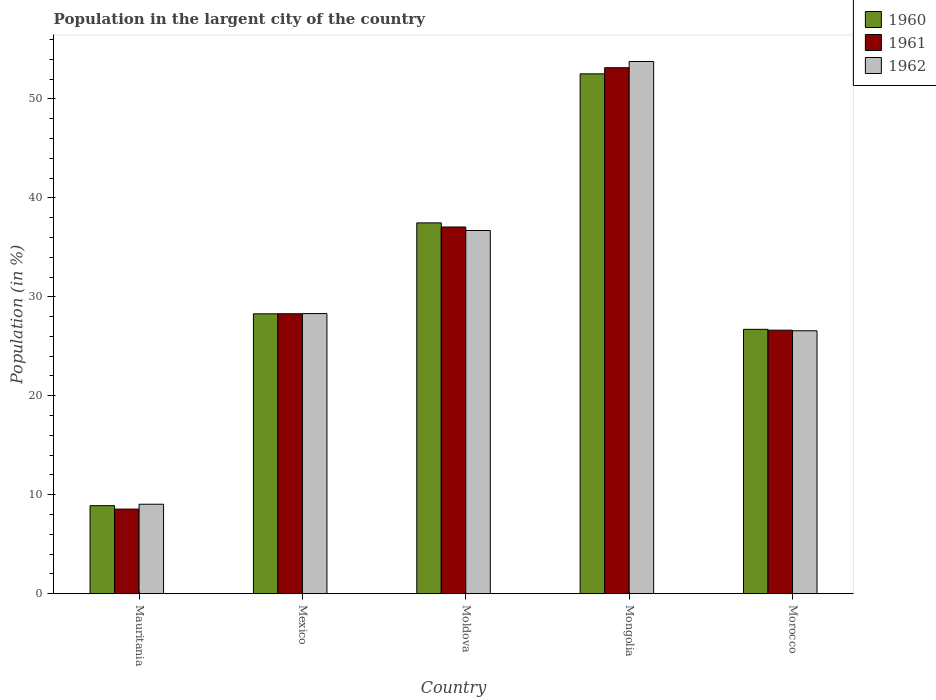How many different coloured bars are there?
Keep it short and to the point. 3. Are the number of bars per tick equal to the number of legend labels?
Offer a very short reply. Yes. How many bars are there on the 5th tick from the left?
Make the answer very short. 3. How many bars are there on the 4th tick from the right?
Keep it short and to the point. 3. What is the label of the 3rd group of bars from the left?
Make the answer very short. Moldova. In how many cases, is the number of bars for a given country not equal to the number of legend labels?
Offer a very short reply. 0. What is the percentage of population in the largent city in 1962 in Moldova?
Provide a succinct answer. 36.7. Across all countries, what is the maximum percentage of population in the largent city in 1962?
Your response must be concise. 53.77. Across all countries, what is the minimum percentage of population in the largent city in 1960?
Keep it short and to the point. 8.9. In which country was the percentage of population in the largent city in 1961 maximum?
Your answer should be compact. Mongolia. In which country was the percentage of population in the largent city in 1962 minimum?
Ensure brevity in your answer.  Mauritania. What is the total percentage of population in the largent city in 1961 in the graph?
Provide a short and direct response. 153.66. What is the difference between the percentage of population in the largent city in 1960 in Moldova and that in Morocco?
Your answer should be compact. 10.76. What is the difference between the percentage of population in the largent city in 1961 in Moldova and the percentage of population in the largent city in 1960 in Mauritania?
Provide a succinct answer. 28.15. What is the average percentage of population in the largent city in 1960 per country?
Provide a short and direct response. 30.78. What is the difference between the percentage of population in the largent city of/in 1961 and percentage of population in the largent city of/in 1960 in Mauritania?
Offer a terse response. -0.35. What is the ratio of the percentage of population in the largent city in 1960 in Moldova to that in Morocco?
Ensure brevity in your answer.  1.4. What is the difference between the highest and the second highest percentage of population in the largent city in 1962?
Your answer should be compact. -8.39. What is the difference between the highest and the lowest percentage of population in the largent city in 1962?
Ensure brevity in your answer.  44.73. In how many countries, is the percentage of population in the largent city in 1961 greater than the average percentage of population in the largent city in 1961 taken over all countries?
Offer a very short reply. 2. Is the sum of the percentage of population in the largent city in 1960 in Mongolia and Morocco greater than the maximum percentage of population in the largent city in 1961 across all countries?
Ensure brevity in your answer.  Yes. What does the 1st bar from the right in Mongolia represents?
Offer a very short reply. 1962. How many bars are there?
Your response must be concise. 15. What is the difference between two consecutive major ticks on the Y-axis?
Ensure brevity in your answer.  10. Does the graph contain any zero values?
Offer a very short reply. No. How many legend labels are there?
Offer a terse response. 3. How are the legend labels stacked?
Offer a very short reply. Vertical. What is the title of the graph?
Ensure brevity in your answer.  Population in the largent city of the country. What is the Population (in %) in 1960 in Mauritania?
Your answer should be very brief. 8.9. What is the Population (in %) in 1961 in Mauritania?
Make the answer very short. 8.55. What is the Population (in %) of 1962 in Mauritania?
Your answer should be compact. 9.04. What is the Population (in %) of 1960 in Mexico?
Your answer should be compact. 28.28. What is the Population (in %) in 1961 in Mexico?
Your answer should be very brief. 28.29. What is the Population (in %) in 1962 in Mexico?
Give a very brief answer. 28.31. What is the Population (in %) of 1960 in Moldova?
Your response must be concise. 37.47. What is the Population (in %) of 1961 in Moldova?
Your answer should be compact. 37.05. What is the Population (in %) in 1962 in Moldova?
Provide a succinct answer. 36.7. What is the Population (in %) in 1960 in Mongolia?
Provide a succinct answer. 52.52. What is the Population (in %) of 1961 in Mongolia?
Your response must be concise. 53.14. What is the Population (in %) in 1962 in Mongolia?
Your response must be concise. 53.77. What is the Population (in %) in 1960 in Morocco?
Keep it short and to the point. 26.71. What is the Population (in %) in 1961 in Morocco?
Make the answer very short. 26.63. What is the Population (in %) of 1962 in Morocco?
Offer a terse response. 26.57. Across all countries, what is the maximum Population (in %) in 1960?
Your answer should be compact. 52.52. Across all countries, what is the maximum Population (in %) in 1961?
Provide a short and direct response. 53.14. Across all countries, what is the maximum Population (in %) of 1962?
Provide a short and direct response. 53.77. Across all countries, what is the minimum Population (in %) of 1960?
Give a very brief answer. 8.9. Across all countries, what is the minimum Population (in %) in 1961?
Keep it short and to the point. 8.55. Across all countries, what is the minimum Population (in %) of 1962?
Offer a terse response. 9.04. What is the total Population (in %) in 1960 in the graph?
Provide a short and direct response. 153.88. What is the total Population (in %) of 1961 in the graph?
Offer a very short reply. 153.66. What is the total Population (in %) in 1962 in the graph?
Your answer should be very brief. 154.39. What is the difference between the Population (in %) in 1960 in Mauritania and that in Mexico?
Your answer should be very brief. -19.38. What is the difference between the Population (in %) in 1961 in Mauritania and that in Mexico?
Offer a very short reply. -19.73. What is the difference between the Population (in %) of 1962 in Mauritania and that in Mexico?
Offer a very short reply. -19.26. What is the difference between the Population (in %) of 1960 in Mauritania and that in Moldova?
Provide a succinct answer. -28.57. What is the difference between the Population (in %) in 1961 in Mauritania and that in Moldova?
Your answer should be compact. -28.5. What is the difference between the Population (in %) in 1962 in Mauritania and that in Moldova?
Your answer should be compact. -27.66. What is the difference between the Population (in %) of 1960 in Mauritania and that in Mongolia?
Your answer should be compact. -43.62. What is the difference between the Population (in %) of 1961 in Mauritania and that in Mongolia?
Your response must be concise. -44.59. What is the difference between the Population (in %) of 1962 in Mauritania and that in Mongolia?
Offer a terse response. -44.73. What is the difference between the Population (in %) of 1960 in Mauritania and that in Morocco?
Ensure brevity in your answer.  -17.81. What is the difference between the Population (in %) in 1961 in Mauritania and that in Morocco?
Make the answer very short. -18.08. What is the difference between the Population (in %) of 1962 in Mauritania and that in Morocco?
Offer a terse response. -17.53. What is the difference between the Population (in %) of 1960 in Mexico and that in Moldova?
Your answer should be very brief. -9.19. What is the difference between the Population (in %) in 1961 in Mexico and that in Moldova?
Make the answer very short. -8.76. What is the difference between the Population (in %) of 1962 in Mexico and that in Moldova?
Your response must be concise. -8.39. What is the difference between the Population (in %) in 1960 in Mexico and that in Mongolia?
Provide a succinct answer. -24.24. What is the difference between the Population (in %) in 1961 in Mexico and that in Mongolia?
Your response must be concise. -24.86. What is the difference between the Population (in %) of 1962 in Mexico and that in Mongolia?
Provide a succinct answer. -25.47. What is the difference between the Population (in %) of 1960 in Mexico and that in Morocco?
Ensure brevity in your answer.  1.57. What is the difference between the Population (in %) of 1961 in Mexico and that in Morocco?
Provide a short and direct response. 1.66. What is the difference between the Population (in %) of 1962 in Mexico and that in Morocco?
Give a very brief answer. 1.74. What is the difference between the Population (in %) of 1960 in Moldova and that in Mongolia?
Offer a very short reply. -15.05. What is the difference between the Population (in %) of 1961 in Moldova and that in Mongolia?
Provide a short and direct response. -16.09. What is the difference between the Population (in %) of 1962 in Moldova and that in Mongolia?
Offer a very short reply. -17.08. What is the difference between the Population (in %) in 1960 in Moldova and that in Morocco?
Offer a very short reply. 10.76. What is the difference between the Population (in %) of 1961 in Moldova and that in Morocco?
Offer a very short reply. 10.42. What is the difference between the Population (in %) of 1962 in Moldova and that in Morocco?
Make the answer very short. 10.13. What is the difference between the Population (in %) of 1960 in Mongolia and that in Morocco?
Keep it short and to the point. 25.81. What is the difference between the Population (in %) of 1961 in Mongolia and that in Morocco?
Offer a terse response. 26.51. What is the difference between the Population (in %) of 1962 in Mongolia and that in Morocco?
Provide a succinct answer. 27.2. What is the difference between the Population (in %) of 1960 in Mauritania and the Population (in %) of 1961 in Mexico?
Make the answer very short. -19.39. What is the difference between the Population (in %) in 1960 in Mauritania and the Population (in %) in 1962 in Mexico?
Offer a terse response. -19.41. What is the difference between the Population (in %) in 1961 in Mauritania and the Population (in %) in 1962 in Mexico?
Your answer should be very brief. -19.75. What is the difference between the Population (in %) of 1960 in Mauritania and the Population (in %) of 1961 in Moldova?
Your answer should be very brief. -28.15. What is the difference between the Population (in %) of 1960 in Mauritania and the Population (in %) of 1962 in Moldova?
Provide a short and direct response. -27.8. What is the difference between the Population (in %) in 1961 in Mauritania and the Population (in %) in 1962 in Moldova?
Give a very brief answer. -28.15. What is the difference between the Population (in %) in 1960 in Mauritania and the Population (in %) in 1961 in Mongolia?
Your response must be concise. -44.24. What is the difference between the Population (in %) in 1960 in Mauritania and the Population (in %) in 1962 in Mongolia?
Offer a terse response. -44.87. What is the difference between the Population (in %) in 1961 in Mauritania and the Population (in %) in 1962 in Mongolia?
Provide a succinct answer. -45.22. What is the difference between the Population (in %) in 1960 in Mauritania and the Population (in %) in 1961 in Morocco?
Provide a succinct answer. -17.73. What is the difference between the Population (in %) in 1960 in Mauritania and the Population (in %) in 1962 in Morocco?
Offer a very short reply. -17.67. What is the difference between the Population (in %) of 1961 in Mauritania and the Population (in %) of 1962 in Morocco?
Ensure brevity in your answer.  -18.02. What is the difference between the Population (in %) in 1960 in Mexico and the Population (in %) in 1961 in Moldova?
Your answer should be compact. -8.77. What is the difference between the Population (in %) of 1960 in Mexico and the Population (in %) of 1962 in Moldova?
Offer a terse response. -8.42. What is the difference between the Population (in %) of 1961 in Mexico and the Population (in %) of 1962 in Moldova?
Your answer should be compact. -8.41. What is the difference between the Population (in %) in 1960 in Mexico and the Population (in %) in 1961 in Mongolia?
Your response must be concise. -24.86. What is the difference between the Population (in %) of 1960 in Mexico and the Population (in %) of 1962 in Mongolia?
Give a very brief answer. -25.49. What is the difference between the Population (in %) of 1961 in Mexico and the Population (in %) of 1962 in Mongolia?
Your answer should be very brief. -25.49. What is the difference between the Population (in %) in 1960 in Mexico and the Population (in %) in 1961 in Morocco?
Make the answer very short. 1.65. What is the difference between the Population (in %) in 1960 in Mexico and the Population (in %) in 1962 in Morocco?
Offer a very short reply. 1.71. What is the difference between the Population (in %) in 1961 in Mexico and the Population (in %) in 1962 in Morocco?
Give a very brief answer. 1.72. What is the difference between the Population (in %) of 1960 in Moldova and the Population (in %) of 1961 in Mongolia?
Offer a terse response. -15.67. What is the difference between the Population (in %) in 1960 in Moldova and the Population (in %) in 1962 in Mongolia?
Your answer should be very brief. -16.3. What is the difference between the Population (in %) of 1961 in Moldova and the Population (in %) of 1962 in Mongolia?
Your answer should be compact. -16.72. What is the difference between the Population (in %) in 1960 in Moldova and the Population (in %) in 1961 in Morocco?
Give a very brief answer. 10.84. What is the difference between the Population (in %) in 1960 in Moldova and the Population (in %) in 1962 in Morocco?
Keep it short and to the point. 10.9. What is the difference between the Population (in %) of 1961 in Moldova and the Population (in %) of 1962 in Morocco?
Your answer should be compact. 10.48. What is the difference between the Population (in %) of 1960 in Mongolia and the Population (in %) of 1961 in Morocco?
Your answer should be very brief. 25.89. What is the difference between the Population (in %) in 1960 in Mongolia and the Population (in %) in 1962 in Morocco?
Your answer should be compact. 25.96. What is the difference between the Population (in %) in 1961 in Mongolia and the Population (in %) in 1962 in Morocco?
Provide a succinct answer. 26.57. What is the average Population (in %) of 1960 per country?
Make the answer very short. 30.78. What is the average Population (in %) of 1961 per country?
Your answer should be very brief. 30.73. What is the average Population (in %) of 1962 per country?
Offer a terse response. 30.88. What is the difference between the Population (in %) of 1960 and Population (in %) of 1961 in Mauritania?
Give a very brief answer. 0.35. What is the difference between the Population (in %) in 1960 and Population (in %) in 1962 in Mauritania?
Provide a short and direct response. -0.14. What is the difference between the Population (in %) in 1961 and Population (in %) in 1962 in Mauritania?
Keep it short and to the point. -0.49. What is the difference between the Population (in %) of 1960 and Population (in %) of 1961 in Mexico?
Provide a succinct answer. -0.01. What is the difference between the Population (in %) in 1960 and Population (in %) in 1962 in Mexico?
Your answer should be compact. -0.02. What is the difference between the Population (in %) of 1961 and Population (in %) of 1962 in Mexico?
Offer a terse response. -0.02. What is the difference between the Population (in %) of 1960 and Population (in %) of 1961 in Moldova?
Your answer should be very brief. 0.42. What is the difference between the Population (in %) in 1960 and Population (in %) in 1962 in Moldova?
Keep it short and to the point. 0.77. What is the difference between the Population (in %) in 1961 and Population (in %) in 1962 in Moldova?
Your answer should be very brief. 0.35. What is the difference between the Population (in %) in 1960 and Population (in %) in 1961 in Mongolia?
Give a very brief answer. -0.62. What is the difference between the Population (in %) of 1960 and Population (in %) of 1962 in Mongolia?
Make the answer very short. -1.25. What is the difference between the Population (in %) in 1961 and Population (in %) in 1962 in Mongolia?
Provide a succinct answer. -0.63. What is the difference between the Population (in %) in 1960 and Population (in %) in 1961 in Morocco?
Your answer should be very brief. 0.08. What is the difference between the Population (in %) of 1960 and Population (in %) of 1962 in Morocco?
Keep it short and to the point. 0.14. What is the difference between the Population (in %) of 1961 and Population (in %) of 1962 in Morocco?
Ensure brevity in your answer.  0.06. What is the ratio of the Population (in %) of 1960 in Mauritania to that in Mexico?
Give a very brief answer. 0.31. What is the ratio of the Population (in %) in 1961 in Mauritania to that in Mexico?
Provide a succinct answer. 0.3. What is the ratio of the Population (in %) of 1962 in Mauritania to that in Mexico?
Your answer should be very brief. 0.32. What is the ratio of the Population (in %) of 1960 in Mauritania to that in Moldova?
Ensure brevity in your answer.  0.24. What is the ratio of the Population (in %) in 1961 in Mauritania to that in Moldova?
Your answer should be very brief. 0.23. What is the ratio of the Population (in %) in 1962 in Mauritania to that in Moldova?
Give a very brief answer. 0.25. What is the ratio of the Population (in %) in 1960 in Mauritania to that in Mongolia?
Provide a succinct answer. 0.17. What is the ratio of the Population (in %) of 1961 in Mauritania to that in Mongolia?
Offer a very short reply. 0.16. What is the ratio of the Population (in %) in 1962 in Mauritania to that in Mongolia?
Your answer should be compact. 0.17. What is the ratio of the Population (in %) in 1960 in Mauritania to that in Morocco?
Give a very brief answer. 0.33. What is the ratio of the Population (in %) of 1961 in Mauritania to that in Morocco?
Your response must be concise. 0.32. What is the ratio of the Population (in %) in 1962 in Mauritania to that in Morocco?
Your response must be concise. 0.34. What is the ratio of the Population (in %) in 1960 in Mexico to that in Moldova?
Provide a short and direct response. 0.75. What is the ratio of the Population (in %) in 1961 in Mexico to that in Moldova?
Your answer should be very brief. 0.76. What is the ratio of the Population (in %) in 1962 in Mexico to that in Moldova?
Your answer should be compact. 0.77. What is the ratio of the Population (in %) in 1960 in Mexico to that in Mongolia?
Provide a short and direct response. 0.54. What is the ratio of the Population (in %) in 1961 in Mexico to that in Mongolia?
Make the answer very short. 0.53. What is the ratio of the Population (in %) in 1962 in Mexico to that in Mongolia?
Provide a short and direct response. 0.53. What is the ratio of the Population (in %) of 1960 in Mexico to that in Morocco?
Keep it short and to the point. 1.06. What is the ratio of the Population (in %) of 1961 in Mexico to that in Morocco?
Make the answer very short. 1.06. What is the ratio of the Population (in %) in 1962 in Mexico to that in Morocco?
Offer a very short reply. 1.07. What is the ratio of the Population (in %) in 1960 in Moldova to that in Mongolia?
Ensure brevity in your answer.  0.71. What is the ratio of the Population (in %) in 1961 in Moldova to that in Mongolia?
Provide a succinct answer. 0.7. What is the ratio of the Population (in %) in 1962 in Moldova to that in Mongolia?
Offer a terse response. 0.68. What is the ratio of the Population (in %) of 1960 in Moldova to that in Morocco?
Offer a very short reply. 1.4. What is the ratio of the Population (in %) of 1961 in Moldova to that in Morocco?
Give a very brief answer. 1.39. What is the ratio of the Population (in %) of 1962 in Moldova to that in Morocco?
Keep it short and to the point. 1.38. What is the ratio of the Population (in %) in 1960 in Mongolia to that in Morocco?
Your response must be concise. 1.97. What is the ratio of the Population (in %) in 1961 in Mongolia to that in Morocco?
Offer a terse response. 2. What is the ratio of the Population (in %) in 1962 in Mongolia to that in Morocco?
Offer a very short reply. 2.02. What is the difference between the highest and the second highest Population (in %) in 1960?
Keep it short and to the point. 15.05. What is the difference between the highest and the second highest Population (in %) of 1961?
Ensure brevity in your answer.  16.09. What is the difference between the highest and the second highest Population (in %) of 1962?
Ensure brevity in your answer.  17.08. What is the difference between the highest and the lowest Population (in %) in 1960?
Give a very brief answer. 43.62. What is the difference between the highest and the lowest Population (in %) of 1961?
Provide a short and direct response. 44.59. What is the difference between the highest and the lowest Population (in %) in 1962?
Your answer should be very brief. 44.73. 